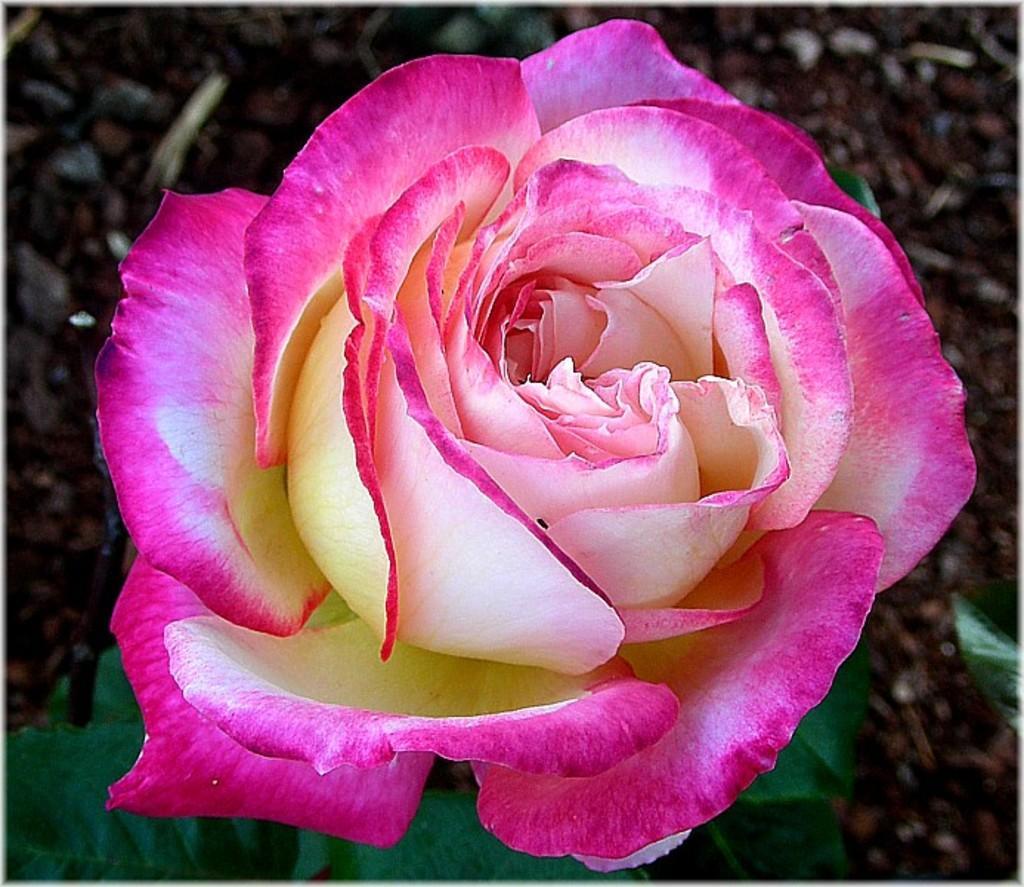How would you summarize this image in a sentence or two? In this image we can see a flower. At the bottom we can see the leaves. Behind the flower we can see the ground. 